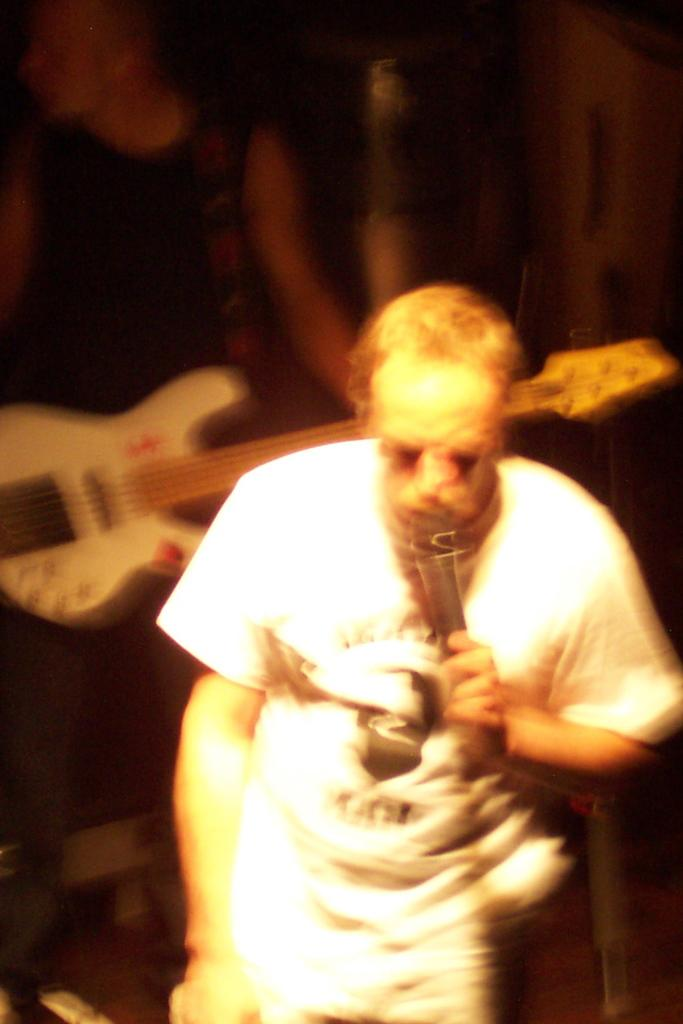What is the person in the white dress doing in the image? The person in the white dress is holding a mic and talking. What is the second person in the image wearing? The second person is wearing a black dress. What is the second person holding in the image? The second person is holding a guitar. Can you see the person in the image smashing a finger on a hill? There is no person smashing a finger on a hill in the image. 